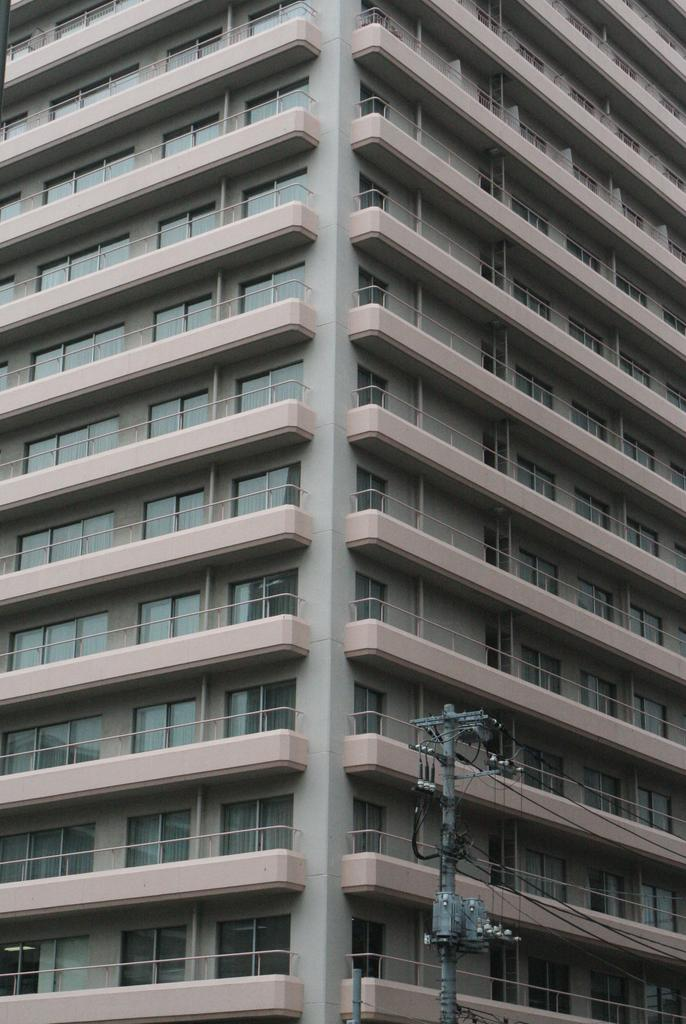What is the main object in the image? There is a pole in the image. Are there any other objects or structures visible? Yes, there are wires and a building in the image. How many pies are stacked on the toes of the person in the image? There is no person or pies present in the image; it only features a pole, wires, and a building. 